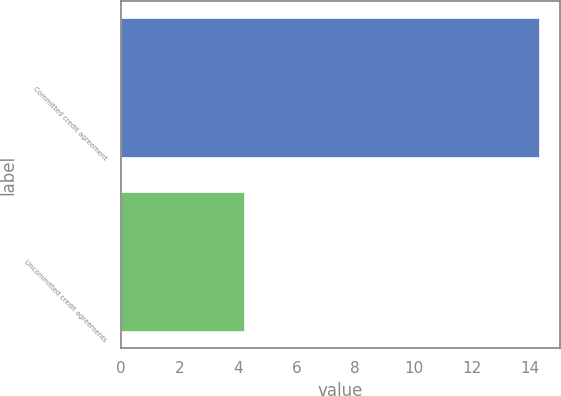<chart> <loc_0><loc_0><loc_500><loc_500><bar_chart><fcel>Committed credit agreement<fcel>Uncommitted credit agreements<nl><fcel>14.3<fcel>4.2<nl></chart> 